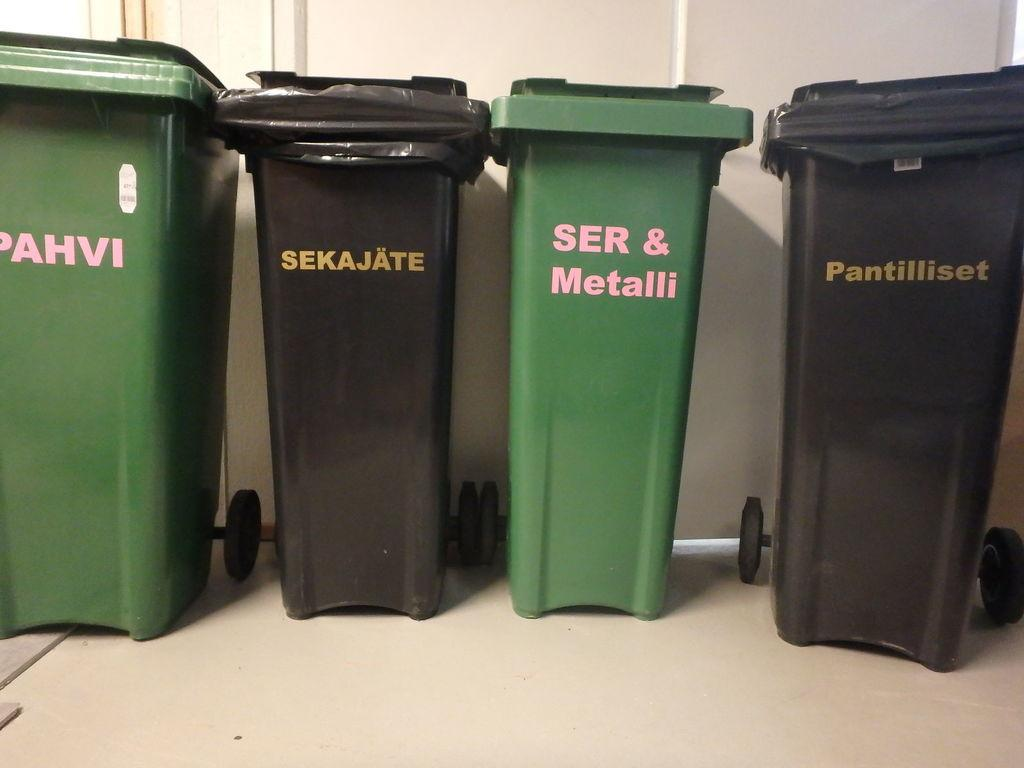<image>
Offer a succinct explanation of the picture presented. A group of four trash cans are shown, one says SER & Metalli and another one says Pantilliset on it. 